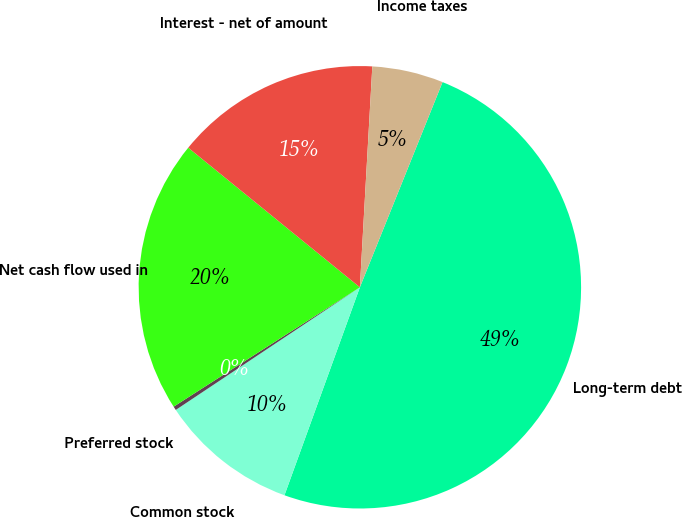<chart> <loc_0><loc_0><loc_500><loc_500><pie_chart><fcel>Long-term debt<fcel>Common stock<fcel>Preferred stock<fcel>Net cash flow used in<fcel>Interest - net of amount<fcel>Income taxes<nl><fcel>49.44%<fcel>10.11%<fcel>0.28%<fcel>19.94%<fcel>15.03%<fcel>5.2%<nl></chart> 